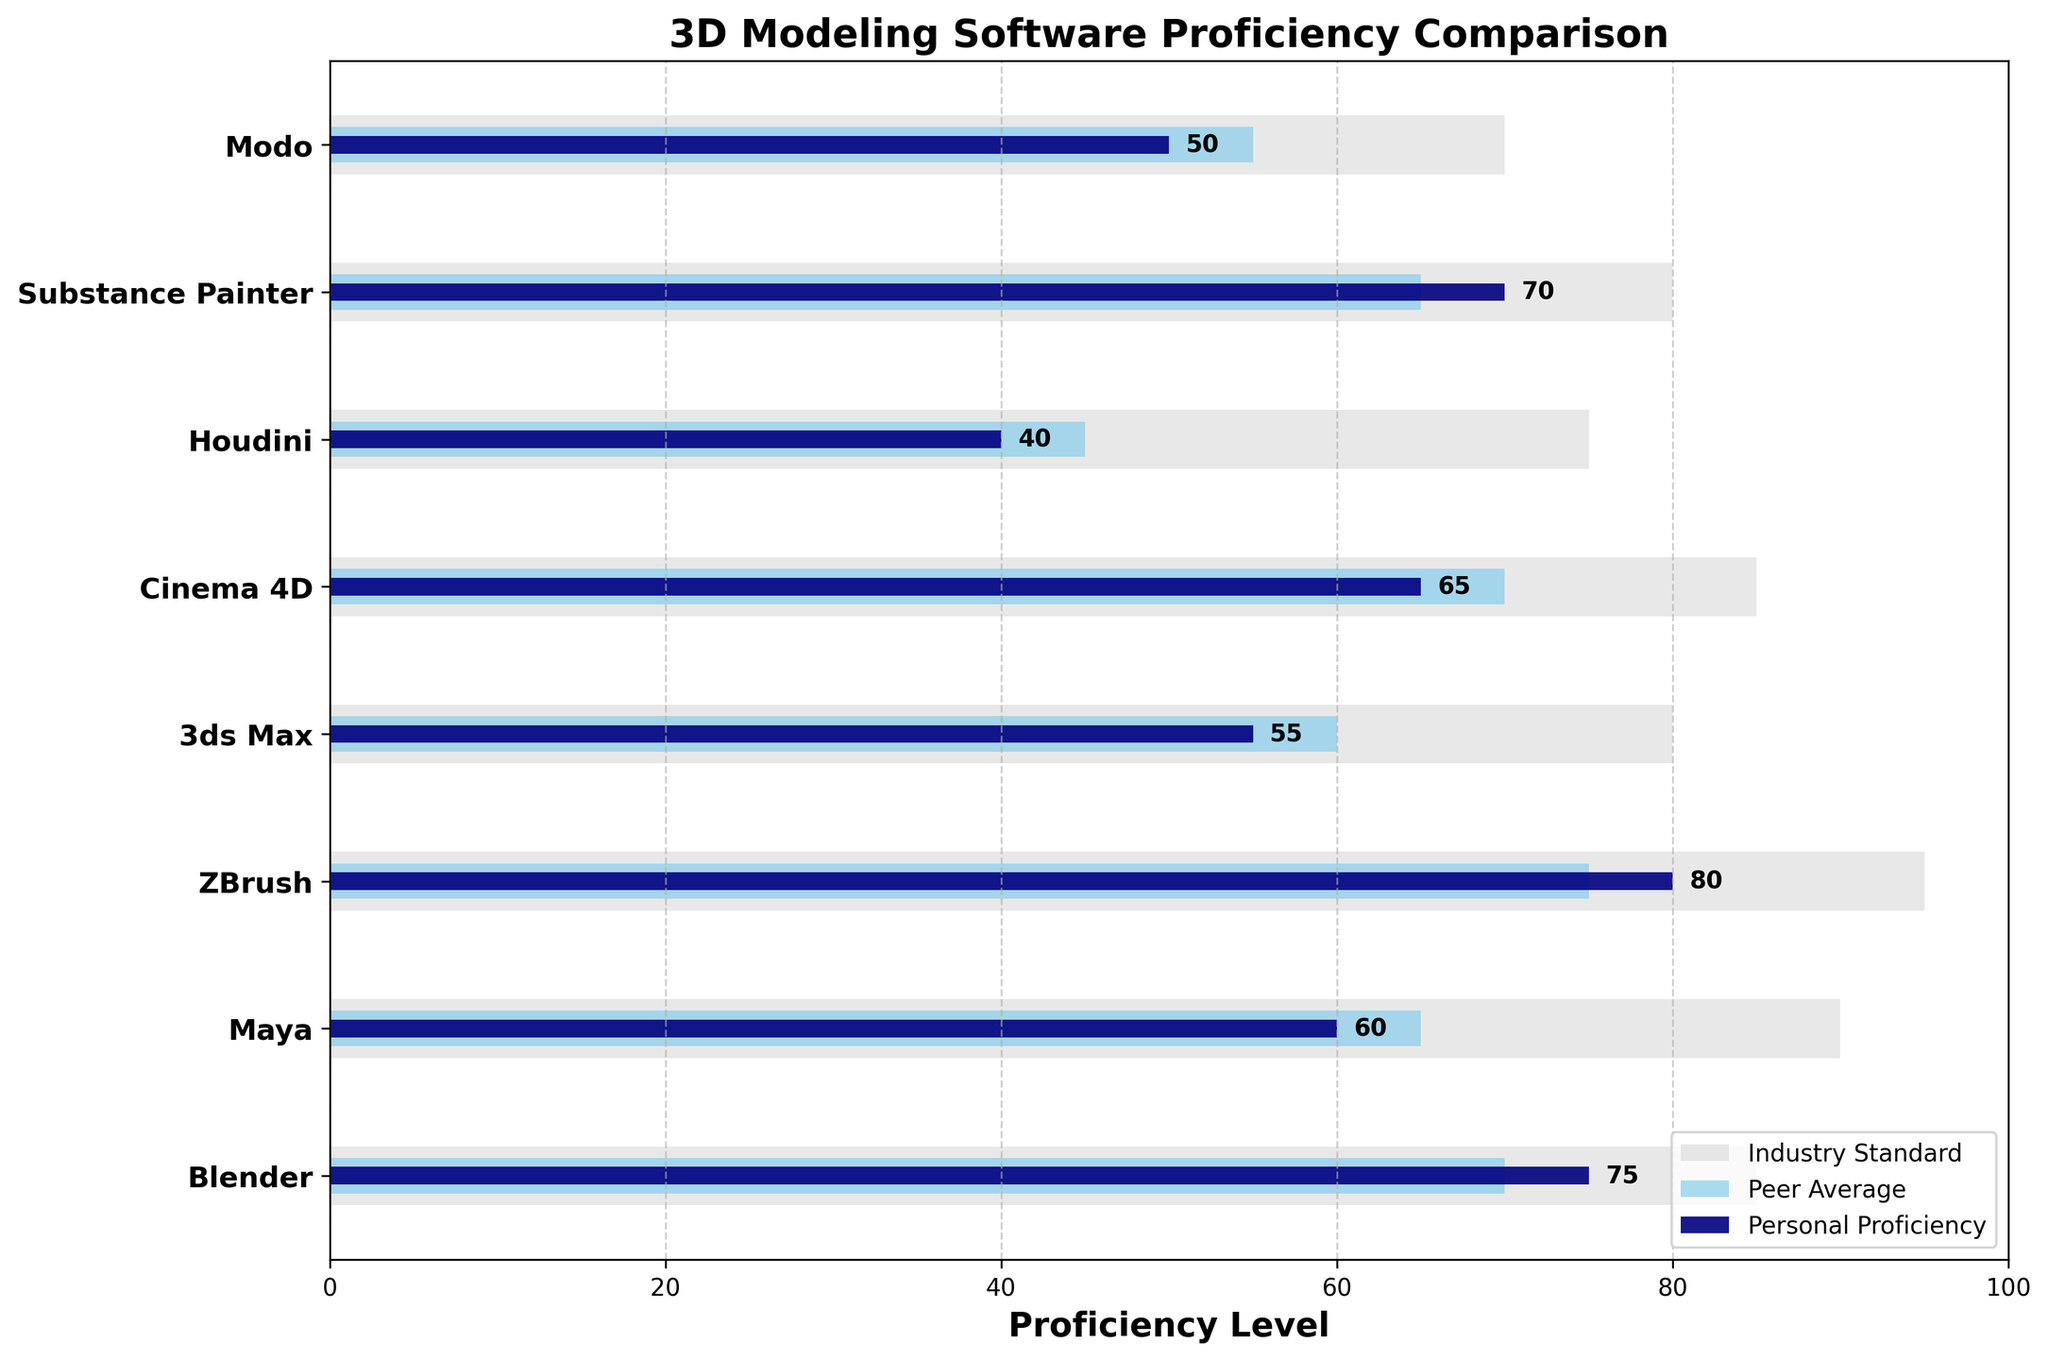Which software has the highest personal proficiency level? By looking at the navy bars indicating personal proficiency levels, we can see which bar reaches the farthest to the right.
Answer: ZBrush What is the average personal proficiency level across all software? Sum the personal proficiency levels and then divide by the number of software: (75+60+80+55+65+40+70+50)/8 = 61.25.
Answer: 61.25 How does the personal proficiency level of Blender compare to the peer average for Maya? Refer to the navy bar for Blender and the skyblue bar for Maya. Blender's personal proficiency is 75 and Maya's peer average is 65. 75 is greater than 65.
Answer: Blender is higher Which software has the smallest gap between personal proficiency and industry standard? Calculate the differences between personal proficiency and industry standard for each software and find the smallest difference: Blender (85-75=10), Maya (90-60=30), ZBrush (95-80=15), 3ds Max (80-55=25), Cinema 4D (85-65=20), Houdini (75-40=35), Substance Painter (80-70=10), Modo (70-50=20). The smallest gap is with Blender and Substance Painter.
Answer: Blender and Substance Painter What percentage of the industry standard is the personal proficiency in Houdini? Divide Houdini's personal proficiency by the industry standard, then multiply by 100: (40/75) * 100 = 53.33%.
Answer: 53.33% What is the difference between the personal proficiency and the industry standard for Cinema 4D? Subtract the personal proficiency level from the industry standard for Cinema 4D. 85 - 65 = 20.
Answer: 20 Which software has the largest peer average? Identify the software with the longest skyblue bar. By comparing all, ZBrush has the largest peer average of 75.
Answer: ZBrush How many software have a personal proficiency level above their peer average? Compare each software's personal proficiency level with its peer average: Blender (75>70), Maya (60<65), ZBrush (80>75), 3ds Max (55<60), Cinema 4D (65<70), Houdini (40<45), Substance Painter (70>65), Modo (50<55). There are 3 cases where personal proficiency is above peer average.
Answer: 3 Which software has the largest discrepancy between peer average and industry standard? Calculate the differences between peer average and industry standard for each software and find the largest: Blender (85-70=15), Maya (90-65=25), ZBrush (95-75=20), 3ds Max (80-60=20), Cinema 4D (85-70=15), Houdini (75-45=30), Substance Painter (80-65=15), Modo (70-55=15). Houdini has the largest discrepancy.
Answer: Houdini What is the median personal proficiency level across all the software? Sort personal proficiency levels and find the middle value(s). Personal proficiency levels sorted: [40, 50, 55, 60, 65, 70, 75, 80]. Median is the average of 60 and 65: (60 + 65) / 2 = 62.5.
Answer: 62.5 